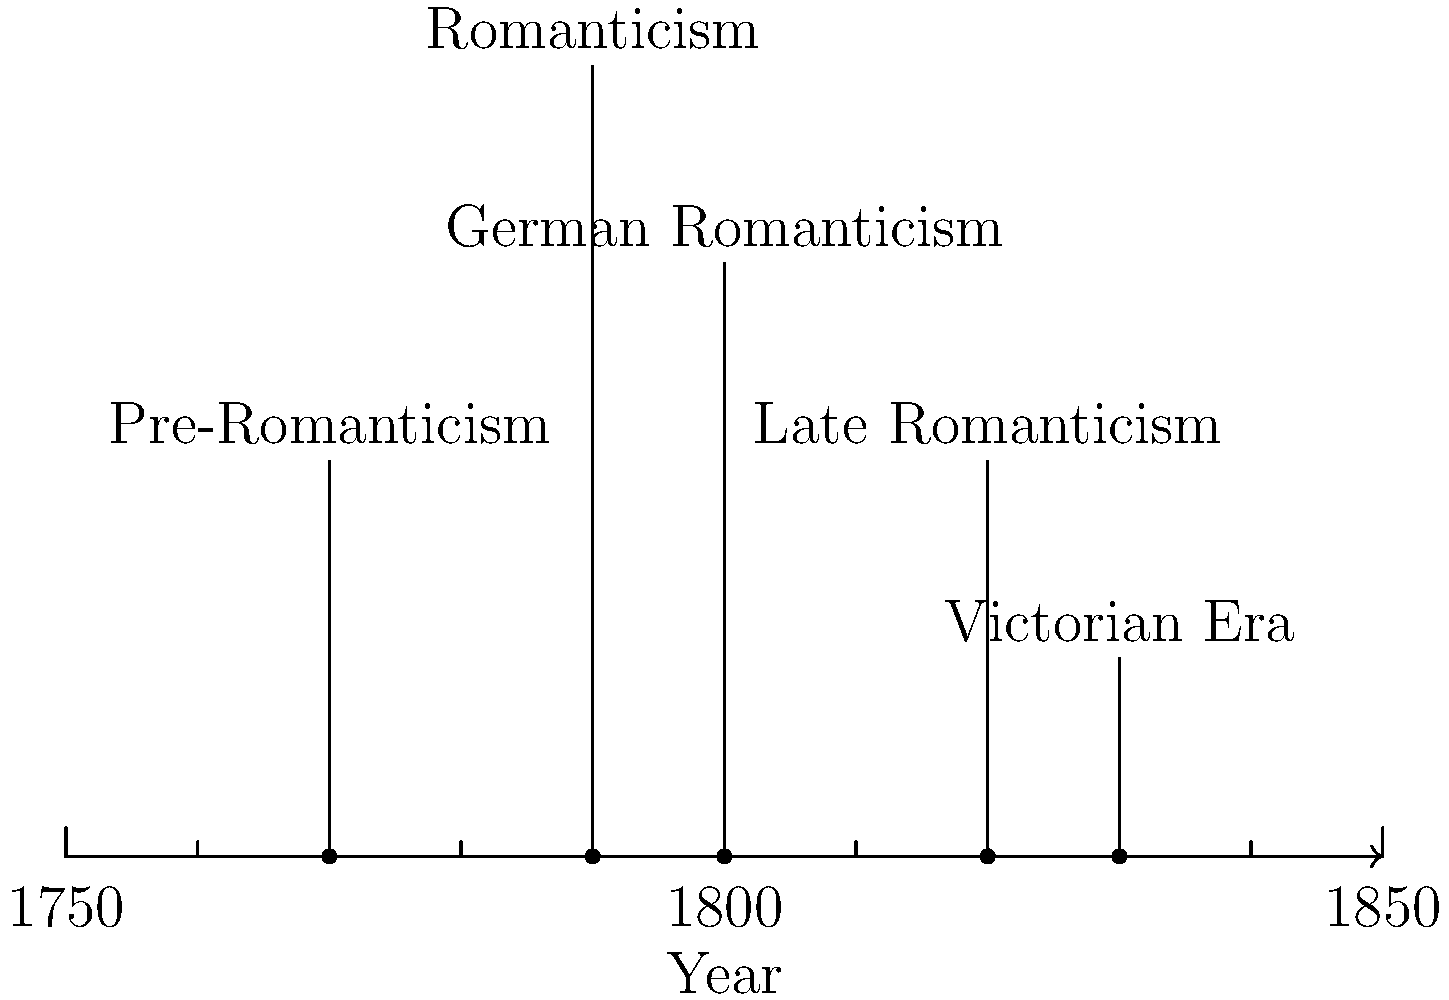Based on the timeline of Romantic literary movements, which movement directly precedes the Victorian Era and represents the final phase of Romanticism? To answer this question, let's analyze the timeline of Romantic literary movements step-by-step:

1. The timeline shows the progression of literary movements from 1750 to 1850.
2. We can identify five key movements on the timeline:
   a. Pre-Romanticism (around 1770)
   b. Romanticism (around 1790)
   c. German Romanticism (around 1800)
   d. Late Romanticism (around 1820)
   e. Victorian Era (around 1830)
3. The question asks for the movement that directly precedes the Victorian Era.
4. Looking at the timeline, we can see that Late Romanticism (around 1820) is the movement immediately before the Victorian Era (around 1830).
5. Late Romanticism is also described as the "final phase of Romanticism" in the question, which aligns with its position on the timeline.

Therefore, the movement that directly precedes the Victorian Era and represents the final phase of Romanticism is Late Romanticism.
Answer: Late Romanticism 